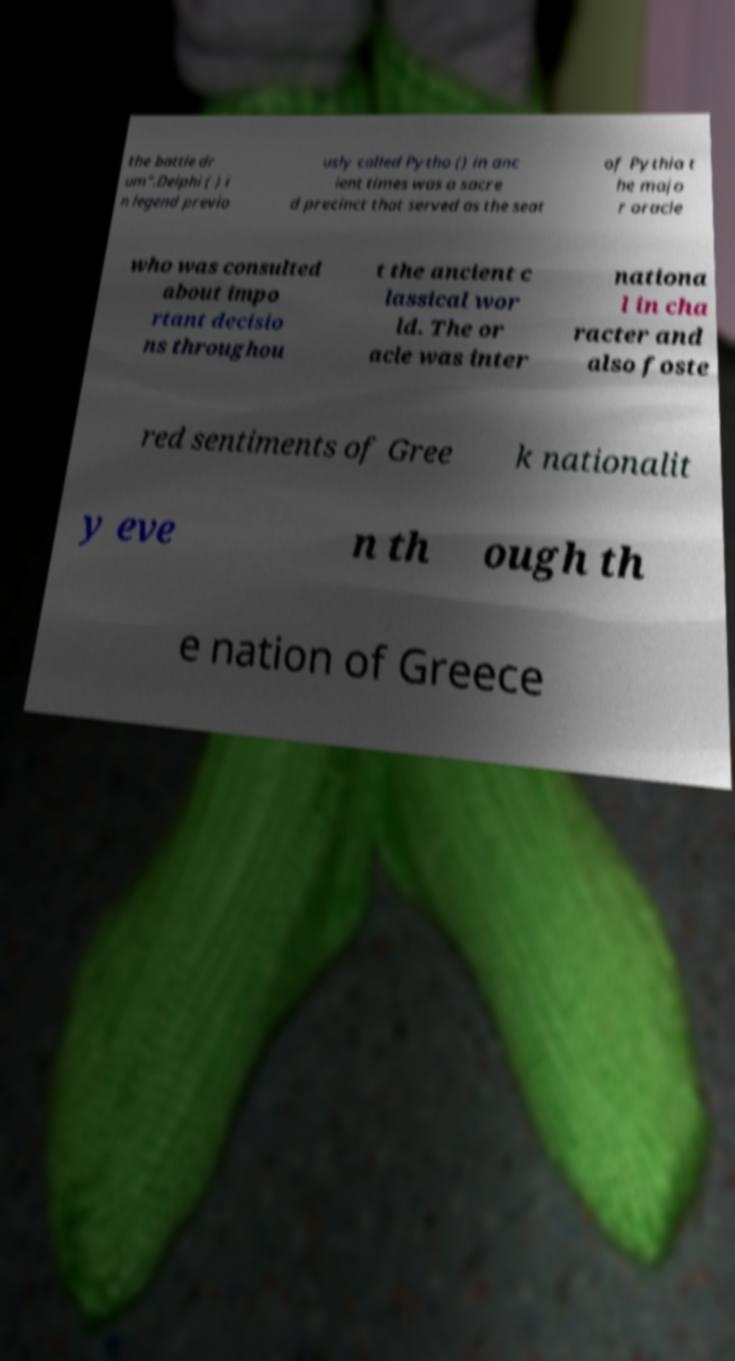Can you accurately transcribe the text from the provided image for me? the battle dr um".Delphi ( ) i n legend previo usly called Pytho () in anc ient times was a sacre d precinct that served as the seat of Pythia t he majo r oracle who was consulted about impo rtant decisio ns throughou t the ancient c lassical wor ld. The or acle was inter nationa l in cha racter and also foste red sentiments of Gree k nationalit y eve n th ough th e nation of Greece 